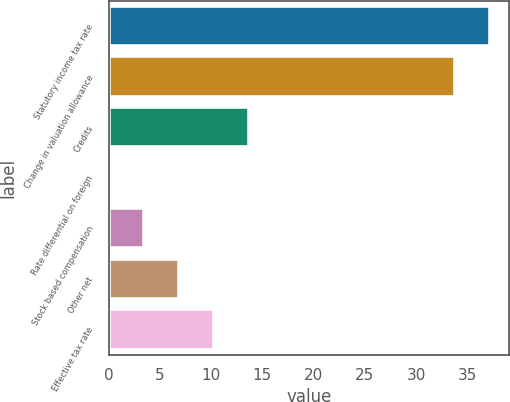<chart> <loc_0><loc_0><loc_500><loc_500><bar_chart><fcel>Statutory income tax rate<fcel>Change in valuation allowance<fcel>Credits<fcel>Rate differential on foreign<fcel>Stock based compensation<fcel>Other net<fcel>Effective tax rate<nl><fcel>37.19<fcel>33.8<fcel>13.66<fcel>0.1<fcel>3.49<fcel>6.88<fcel>10.27<nl></chart> 